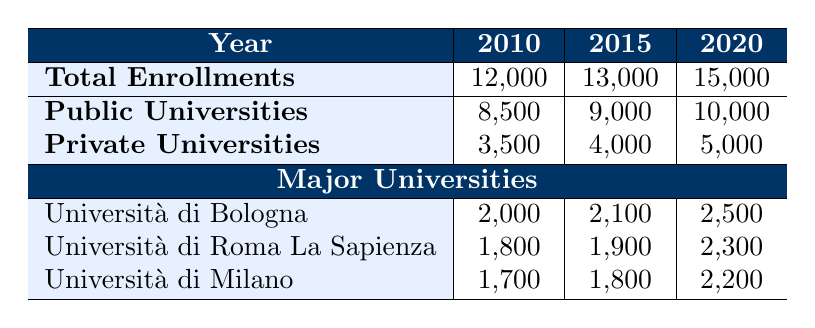What was the total enrollment of History majors in 2010? The table directly shows that in 2010, the total enrollments for History majors were 12,000.
Answer: 12,000 How many enrollments were recorded for private universities in 2015? Referring to the table, it indicates that private universities had 4,000 enrollments in 2015.
Answer: 4,000 Which university had the highest enrollments in 2020, and how many were there? The table lists the universities for 2020, with Università di Bologna having 2,500 enrollments, the highest among the three.
Answer: Università di Bologna, 2,500 What is the difference in total enrollments between 2020 and 2010? To find the difference, subtract the total enrollments in 2010 (12,000) from that in 2020 (15,000): 15,000 - 12,000 = 3,000.
Answer: 3,000 Did the total enrollments increase from 2010 to 2015? Yes, comparing the totals, 2010 had 12,000 enrollments and 2015 had 13,000, indicating an increase.
Answer: Yes What is the total number of enrollments across all major universities in 2015? To calculate this, sum the enrollments for each major university in 2015: 2,100 (Bologna) + 1,900 (Roma La Sapienza) + 1,800 (Milano) = 5,800.
Answer: 5,800 How many more students enrolled in public universities than private ones in 2020? In 2020, public universities had 10,000 enrollments while private universities had 5,000. The difference is 10,000 - 5,000 = 5,000.
Answer: 5,000 What was the average enrollment for Università di Roma La Sapienza over the three years? The total enrollments over the three years are 1,800 (2010), 1,900 (2015), and 2,300 (2020). The average is (1,800 + 1,900 + 2,300) / 3 = 2,000.
Answer: 2,000 Which year saw the largest increase in enrollments compared to the previous year? By examining the increases: from 2010 to 2015, it was 1,000; from 2015 to 2020, it was 2,000. The largest increase was from 2015 to 2020, which was 2,000.
Answer: 2020 